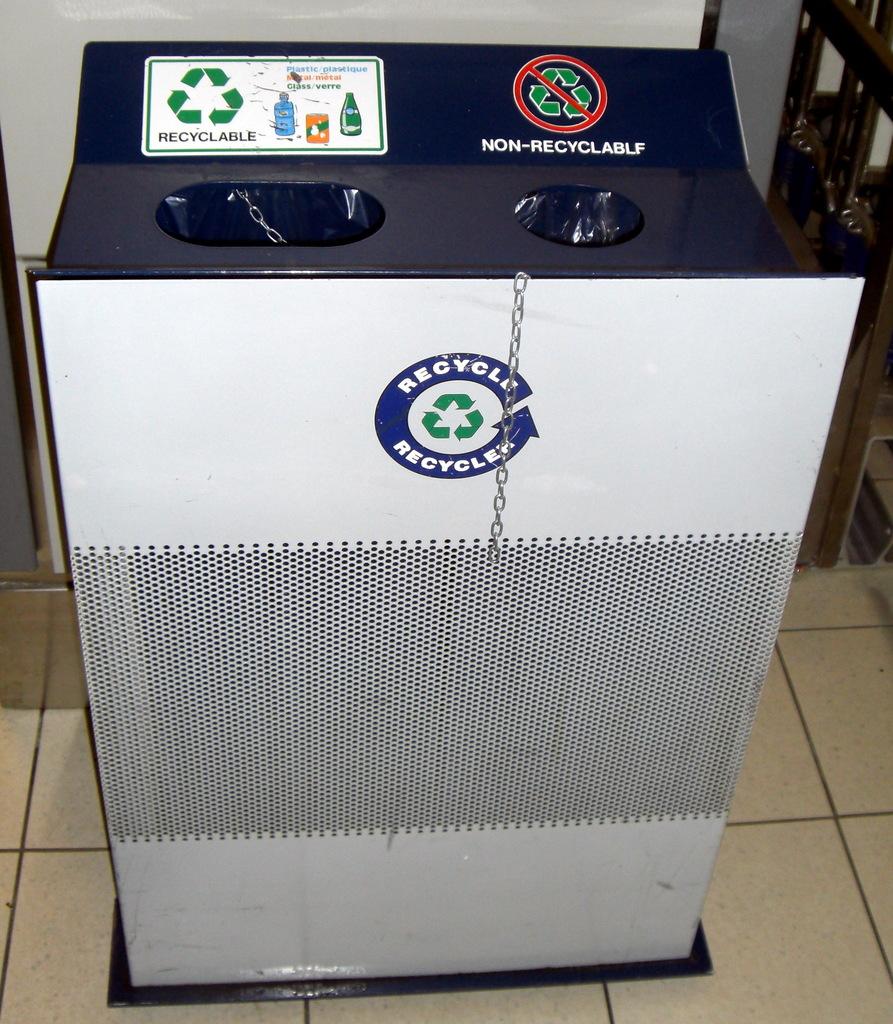This is used for what activity?
Provide a succinct answer. Recycling. What does it say on the top right hole?
Your response must be concise. Non-recyclable. 